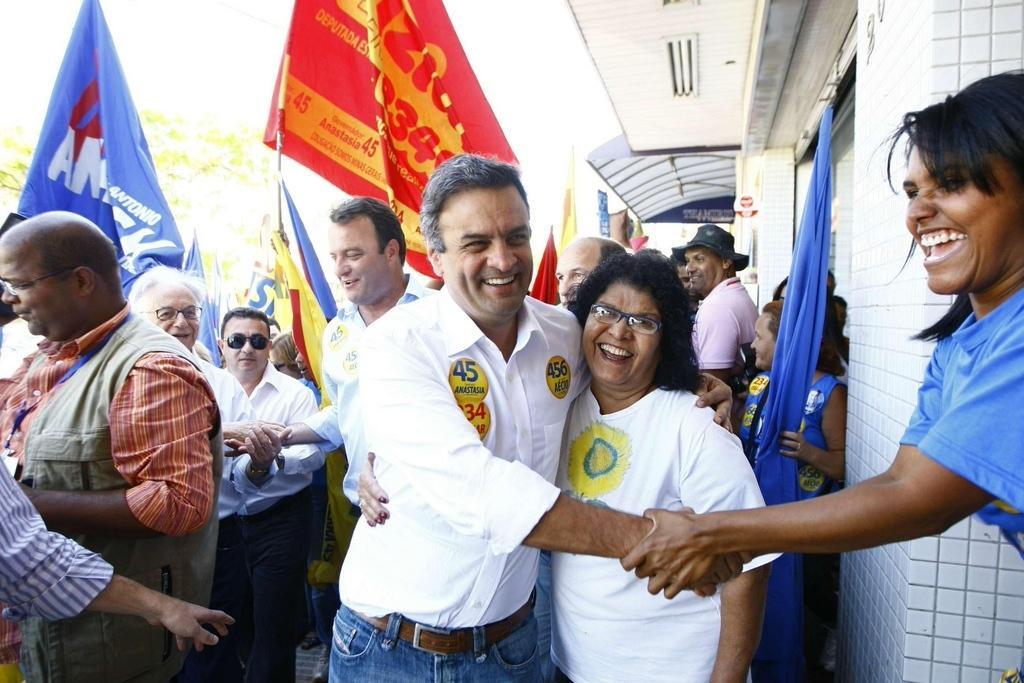Could you give a brief overview of what you see in this image? In this image we can see there are a few people standing and holding some flags and some are shake handing to each other with a smile on their face. On the right side of the image there are some buildings. 